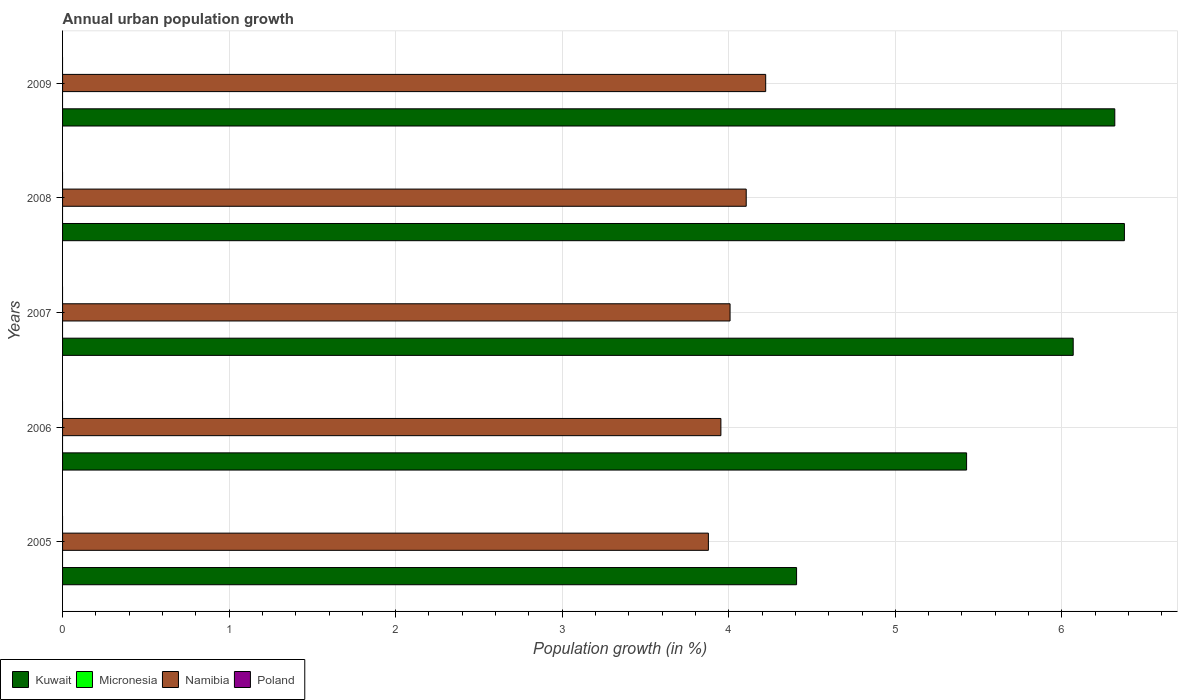How many different coloured bars are there?
Your response must be concise. 2. Are the number of bars per tick equal to the number of legend labels?
Your response must be concise. No. Are the number of bars on each tick of the Y-axis equal?
Offer a terse response. Yes. How many bars are there on the 5th tick from the top?
Offer a very short reply. 2. What is the percentage of urban population growth in Micronesia in 2008?
Provide a succinct answer. 0. Across all years, what is the maximum percentage of urban population growth in Namibia?
Your answer should be compact. 4.22. Across all years, what is the minimum percentage of urban population growth in Micronesia?
Keep it short and to the point. 0. In which year was the percentage of urban population growth in Namibia maximum?
Provide a succinct answer. 2009. What is the difference between the percentage of urban population growth in Namibia in 2006 and that in 2008?
Give a very brief answer. -0.15. What is the difference between the percentage of urban population growth in Micronesia in 2006 and the percentage of urban population growth in Namibia in 2007?
Your answer should be compact. -4.01. In how many years, is the percentage of urban population growth in Namibia greater than 3.2 %?
Your answer should be very brief. 5. What is the ratio of the percentage of urban population growth in Namibia in 2005 to that in 2009?
Your answer should be compact. 0.92. What is the difference between the highest and the second highest percentage of urban population growth in Namibia?
Ensure brevity in your answer.  0.12. What is the difference between the highest and the lowest percentage of urban population growth in Namibia?
Give a very brief answer. 0.34. In how many years, is the percentage of urban population growth in Kuwait greater than the average percentage of urban population growth in Kuwait taken over all years?
Your response must be concise. 3. Is it the case that in every year, the sum of the percentage of urban population growth in Micronesia and percentage of urban population growth in Namibia is greater than the sum of percentage of urban population growth in Poland and percentage of urban population growth in Kuwait?
Your answer should be very brief. No. Are all the bars in the graph horizontal?
Keep it short and to the point. Yes. Are the values on the major ticks of X-axis written in scientific E-notation?
Your answer should be compact. No. Where does the legend appear in the graph?
Your answer should be compact. Bottom left. How many legend labels are there?
Your response must be concise. 4. What is the title of the graph?
Give a very brief answer. Annual urban population growth. What is the label or title of the X-axis?
Give a very brief answer. Population growth (in %). What is the label or title of the Y-axis?
Your response must be concise. Years. What is the Population growth (in %) of Kuwait in 2005?
Ensure brevity in your answer.  4.41. What is the Population growth (in %) in Namibia in 2005?
Provide a short and direct response. 3.88. What is the Population growth (in %) in Poland in 2005?
Provide a succinct answer. 0. What is the Population growth (in %) of Kuwait in 2006?
Keep it short and to the point. 5.43. What is the Population growth (in %) in Namibia in 2006?
Your response must be concise. 3.95. What is the Population growth (in %) in Poland in 2006?
Your answer should be very brief. 0. What is the Population growth (in %) in Kuwait in 2007?
Offer a terse response. 6.07. What is the Population growth (in %) of Micronesia in 2007?
Your response must be concise. 0. What is the Population growth (in %) in Namibia in 2007?
Keep it short and to the point. 4.01. What is the Population growth (in %) in Poland in 2007?
Ensure brevity in your answer.  0. What is the Population growth (in %) in Kuwait in 2008?
Give a very brief answer. 6.38. What is the Population growth (in %) of Namibia in 2008?
Your answer should be very brief. 4.1. What is the Population growth (in %) in Kuwait in 2009?
Make the answer very short. 6.32. What is the Population growth (in %) in Namibia in 2009?
Offer a very short reply. 4.22. Across all years, what is the maximum Population growth (in %) of Kuwait?
Your answer should be very brief. 6.38. Across all years, what is the maximum Population growth (in %) in Namibia?
Make the answer very short. 4.22. Across all years, what is the minimum Population growth (in %) in Kuwait?
Your answer should be compact. 4.41. Across all years, what is the minimum Population growth (in %) of Namibia?
Give a very brief answer. 3.88. What is the total Population growth (in %) in Kuwait in the graph?
Keep it short and to the point. 28.6. What is the total Population growth (in %) of Namibia in the graph?
Ensure brevity in your answer.  20.16. What is the total Population growth (in %) in Poland in the graph?
Provide a short and direct response. 0. What is the difference between the Population growth (in %) in Kuwait in 2005 and that in 2006?
Offer a terse response. -1.02. What is the difference between the Population growth (in %) of Namibia in 2005 and that in 2006?
Ensure brevity in your answer.  -0.07. What is the difference between the Population growth (in %) of Kuwait in 2005 and that in 2007?
Provide a short and direct response. -1.66. What is the difference between the Population growth (in %) in Namibia in 2005 and that in 2007?
Ensure brevity in your answer.  -0.13. What is the difference between the Population growth (in %) in Kuwait in 2005 and that in 2008?
Give a very brief answer. -1.97. What is the difference between the Population growth (in %) in Namibia in 2005 and that in 2008?
Offer a very short reply. -0.23. What is the difference between the Population growth (in %) in Kuwait in 2005 and that in 2009?
Provide a short and direct response. -1.91. What is the difference between the Population growth (in %) of Namibia in 2005 and that in 2009?
Offer a terse response. -0.34. What is the difference between the Population growth (in %) of Kuwait in 2006 and that in 2007?
Offer a terse response. -0.64. What is the difference between the Population growth (in %) in Namibia in 2006 and that in 2007?
Your response must be concise. -0.06. What is the difference between the Population growth (in %) of Kuwait in 2006 and that in 2008?
Your response must be concise. -0.95. What is the difference between the Population growth (in %) in Namibia in 2006 and that in 2008?
Your answer should be compact. -0.15. What is the difference between the Population growth (in %) in Kuwait in 2006 and that in 2009?
Offer a terse response. -0.89. What is the difference between the Population growth (in %) of Namibia in 2006 and that in 2009?
Your response must be concise. -0.27. What is the difference between the Population growth (in %) of Kuwait in 2007 and that in 2008?
Provide a short and direct response. -0.31. What is the difference between the Population growth (in %) of Namibia in 2007 and that in 2008?
Ensure brevity in your answer.  -0.1. What is the difference between the Population growth (in %) of Kuwait in 2007 and that in 2009?
Offer a very short reply. -0.25. What is the difference between the Population growth (in %) of Namibia in 2007 and that in 2009?
Your answer should be compact. -0.21. What is the difference between the Population growth (in %) in Kuwait in 2008 and that in 2009?
Make the answer very short. 0.06. What is the difference between the Population growth (in %) of Namibia in 2008 and that in 2009?
Offer a very short reply. -0.12. What is the difference between the Population growth (in %) in Kuwait in 2005 and the Population growth (in %) in Namibia in 2006?
Provide a short and direct response. 0.45. What is the difference between the Population growth (in %) of Kuwait in 2005 and the Population growth (in %) of Namibia in 2007?
Offer a terse response. 0.4. What is the difference between the Population growth (in %) of Kuwait in 2005 and the Population growth (in %) of Namibia in 2008?
Your response must be concise. 0.3. What is the difference between the Population growth (in %) of Kuwait in 2005 and the Population growth (in %) of Namibia in 2009?
Give a very brief answer. 0.19. What is the difference between the Population growth (in %) of Kuwait in 2006 and the Population growth (in %) of Namibia in 2007?
Your answer should be compact. 1.42. What is the difference between the Population growth (in %) of Kuwait in 2006 and the Population growth (in %) of Namibia in 2008?
Offer a terse response. 1.32. What is the difference between the Population growth (in %) in Kuwait in 2006 and the Population growth (in %) in Namibia in 2009?
Give a very brief answer. 1.21. What is the difference between the Population growth (in %) in Kuwait in 2007 and the Population growth (in %) in Namibia in 2008?
Your response must be concise. 1.96. What is the difference between the Population growth (in %) of Kuwait in 2007 and the Population growth (in %) of Namibia in 2009?
Your response must be concise. 1.85. What is the difference between the Population growth (in %) in Kuwait in 2008 and the Population growth (in %) in Namibia in 2009?
Your answer should be compact. 2.15. What is the average Population growth (in %) in Kuwait per year?
Provide a succinct answer. 5.72. What is the average Population growth (in %) in Micronesia per year?
Your answer should be compact. 0. What is the average Population growth (in %) in Namibia per year?
Keep it short and to the point. 4.03. What is the average Population growth (in %) of Poland per year?
Your answer should be compact. 0. In the year 2005, what is the difference between the Population growth (in %) of Kuwait and Population growth (in %) of Namibia?
Your answer should be compact. 0.53. In the year 2006, what is the difference between the Population growth (in %) of Kuwait and Population growth (in %) of Namibia?
Offer a very short reply. 1.48. In the year 2007, what is the difference between the Population growth (in %) in Kuwait and Population growth (in %) in Namibia?
Make the answer very short. 2.06. In the year 2008, what is the difference between the Population growth (in %) in Kuwait and Population growth (in %) in Namibia?
Keep it short and to the point. 2.27. In the year 2009, what is the difference between the Population growth (in %) of Kuwait and Population growth (in %) of Namibia?
Offer a very short reply. 2.1. What is the ratio of the Population growth (in %) of Kuwait in 2005 to that in 2006?
Provide a succinct answer. 0.81. What is the ratio of the Population growth (in %) in Kuwait in 2005 to that in 2007?
Make the answer very short. 0.73. What is the ratio of the Population growth (in %) of Namibia in 2005 to that in 2007?
Your answer should be compact. 0.97. What is the ratio of the Population growth (in %) in Kuwait in 2005 to that in 2008?
Provide a succinct answer. 0.69. What is the ratio of the Population growth (in %) in Namibia in 2005 to that in 2008?
Your response must be concise. 0.94. What is the ratio of the Population growth (in %) of Kuwait in 2005 to that in 2009?
Ensure brevity in your answer.  0.7. What is the ratio of the Population growth (in %) in Namibia in 2005 to that in 2009?
Your answer should be very brief. 0.92. What is the ratio of the Population growth (in %) of Kuwait in 2006 to that in 2007?
Your answer should be very brief. 0.89. What is the ratio of the Population growth (in %) of Namibia in 2006 to that in 2007?
Provide a succinct answer. 0.99. What is the ratio of the Population growth (in %) of Kuwait in 2006 to that in 2008?
Provide a short and direct response. 0.85. What is the ratio of the Population growth (in %) in Namibia in 2006 to that in 2008?
Give a very brief answer. 0.96. What is the ratio of the Population growth (in %) in Kuwait in 2006 to that in 2009?
Your answer should be very brief. 0.86. What is the ratio of the Population growth (in %) in Namibia in 2006 to that in 2009?
Ensure brevity in your answer.  0.94. What is the ratio of the Population growth (in %) in Kuwait in 2007 to that in 2008?
Give a very brief answer. 0.95. What is the ratio of the Population growth (in %) of Namibia in 2007 to that in 2008?
Your response must be concise. 0.98. What is the ratio of the Population growth (in %) in Kuwait in 2007 to that in 2009?
Your answer should be very brief. 0.96. What is the ratio of the Population growth (in %) in Namibia in 2007 to that in 2009?
Provide a succinct answer. 0.95. What is the ratio of the Population growth (in %) of Kuwait in 2008 to that in 2009?
Your response must be concise. 1.01. What is the ratio of the Population growth (in %) of Namibia in 2008 to that in 2009?
Ensure brevity in your answer.  0.97. What is the difference between the highest and the second highest Population growth (in %) in Kuwait?
Your answer should be compact. 0.06. What is the difference between the highest and the second highest Population growth (in %) of Namibia?
Give a very brief answer. 0.12. What is the difference between the highest and the lowest Population growth (in %) of Kuwait?
Your answer should be compact. 1.97. What is the difference between the highest and the lowest Population growth (in %) in Namibia?
Give a very brief answer. 0.34. 